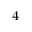Convert formula to latex. <formula><loc_0><loc_0><loc_500><loc_500>_ { 4 }</formula> 